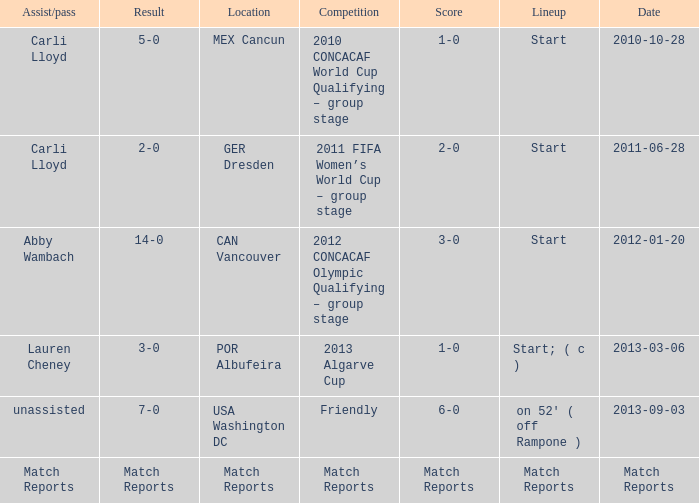Which Assist/pass has a Score of 1-0,a Competition of 2010 concacaf world cup qualifying – group stage? Carli Lloyd. 